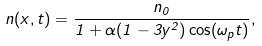<formula> <loc_0><loc_0><loc_500><loc_500>n ( x , t ) = \frac { n _ { 0 } } { 1 + \alpha ( 1 - 3 y ^ { 2 } ) \cos ( \omega _ { p } t ) } ,</formula> 